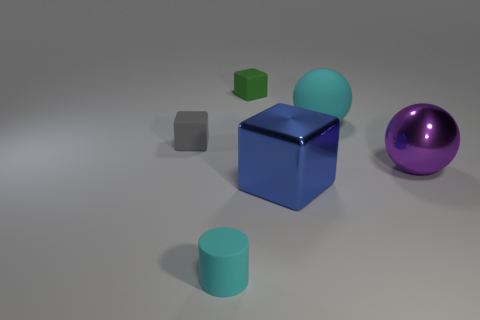There is a cyan rubber object behind the cylinder; what size is it?
Provide a succinct answer. Large. Is there a big sphere that has the same color as the cylinder?
Ensure brevity in your answer.  Yes. Is the color of the small matte cylinder the same as the rubber sphere?
Your answer should be very brief. Yes. There is a thing that is the same color as the big rubber ball; what is its shape?
Offer a very short reply. Cylinder. There is a cyan object in front of the big metal sphere; what number of tiny green rubber blocks are in front of it?
Offer a terse response. 0. What number of cyan cubes are the same material as the tiny gray cube?
Offer a very short reply. 0. Are there any small green rubber blocks right of the tiny cyan cylinder?
Provide a short and direct response. Yes. There is a shiny block that is the same size as the metallic ball; what is its color?
Provide a short and direct response. Blue. How many things are cyan matte objects in front of the blue cube or red matte blocks?
Offer a very short reply. 1. There is a object that is both in front of the metal sphere and to the right of the green block; what is its size?
Offer a terse response. Large. 